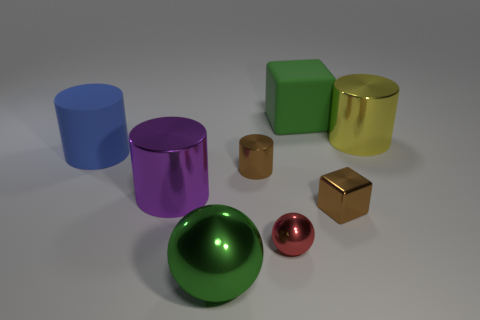What is the small object that is behind the tiny red ball and to the left of the large matte block made of?
Make the answer very short. Metal. There is a yellow object that is the same size as the purple thing; what is its material?
Ensure brevity in your answer.  Metal. What is the size of the matte thing to the left of the green thing behind the big matte object that is left of the big ball?
Make the answer very short. Large. What is the size of the red thing that is made of the same material as the big yellow cylinder?
Ensure brevity in your answer.  Small. There is a blue matte cylinder; is its size the same as the block that is behind the large blue rubber cylinder?
Make the answer very short. Yes. There is a brown metallic thing that is in front of the brown metal cylinder; what shape is it?
Make the answer very short. Cube. Is there a large shiny sphere behind the metallic sphere that is right of the big thing that is in front of the purple object?
Your answer should be very brief. No. What is the material of the other thing that is the same shape as the large green rubber object?
Provide a succinct answer. Metal. Is there anything else that has the same material as the large blue thing?
Provide a short and direct response. Yes. How many blocks are tiny blue shiny things or big green shiny things?
Provide a succinct answer. 0. 